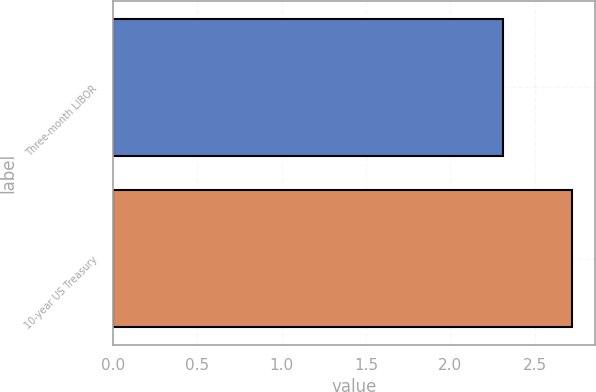<chart> <loc_0><loc_0><loc_500><loc_500><bar_chart><fcel>Three-month LIBOR<fcel>10-year US Treasury<nl><fcel>2.31<fcel>2.72<nl></chart> 